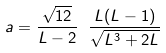Convert formula to latex. <formula><loc_0><loc_0><loc_500><loc_500>a = \frac { \sqrt { 1 2 } } { L - 2 } \ \frac { L ( L - 1 ) } { \sqrt { L ^ { 3 } + 2 L } }</formula> 